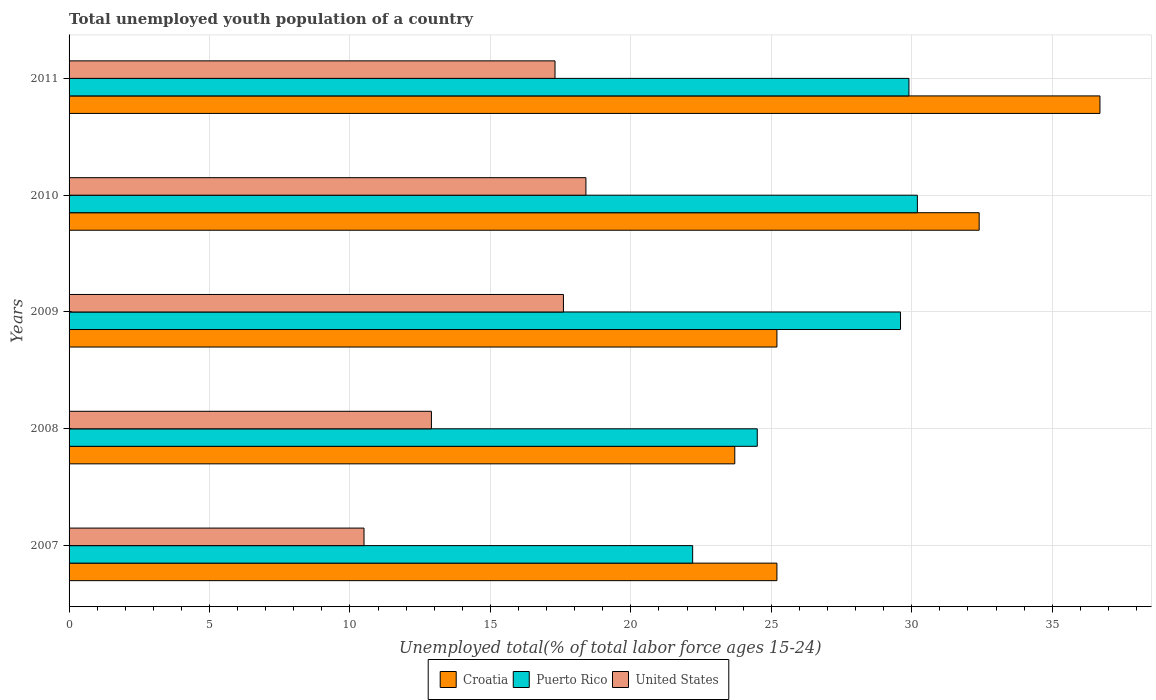Are the number of bars per tick equal to the number of legend labels?
Provide a short and direct response. Yes. How many bars are there on the 2nd tick from the top?
Ensure brevity in your answer.  3. In how many cases, is the number of bars for a given year not equal to the number of legend labels?
Your answer should be compact. 0. What is the percentage of total unemployed youth population of a country in Puerto Rico in 2011?
Your answer should be compact. 29.9. Across all years, what is the maximum percentage of total unemployed youth population of a country in United States?
Make the answer very short. 18.4. Across all years, what is the minimum percentage of total unemployed youth population of a country in Croatia?
Your answer should be very brief. 23.7. In which year was the percentage of total unemployed youth population of a country in Puerto Rico minimum?
Give a very brief answer. 2007. What is the total percentage of total unemployed youth population of a country in Croatia in the graph?
Your answer should be very brief. 143.2. What is the difference between the percentage of total unemployed youth population of a country in Croatia in 2009 and that in 2010?
Give a very brief answer. -7.2. What is the difference between the percentage of total unemployed youth population of a country in Puerto Rico in 2010 and the percentage of total unemployed youth population of a country in United States in 2011?
Make the answer very short. 12.9. What is the average percentage of total unemployed youth population of a country in United States per year?
Provide a succinct answer. 15.34. In the year 2009, what is the difference between the percentage of total unemployed youth population of a country in United States and percentage of total unemployed youth population of a country in Puerto Rico?
Your answer should be very brief. -12. What is the ratio of the percentage of total unemployed youth population of a country in Puerto Rico in 2009 to that in 2010?
Your answer should be very brief. 0.98. Is the percentage of total unemployed youth population of a country in Croatia in 2009 less than that in 2011?
Offer a very short reply. Yes. What is the difference between the highest and the second highest percentage of total unemployed youth population of a country in Croatia?
Offer a terse response. 4.3. What is the difference between the highest and the lowest percentage of total unemployed youth population of a country in Croatia?
Give a very brief answer. 13. What does the 3rd bar from the top in 2010 represents?
Provide a short and direct response. Croatia. What does the 1st bar from the bottom in 2009 represents?
Make the answer very short. Croatia. Is it the case that in every year, the sum of the percentage of total unemployed youth population of a country in Croatia and percentage of total unemployed youth population of a country in Puerto Rico is greater than the percentage of total unemployed youth population of a country in United States?
Give a very brief answer. Yes. How many bars are there?
Offer a very short reply. 15. Does the graph contain any zero values?
Your answer should be very brief. No. Where does the legend appear in the graph?
Give a very brief answer. Bottom center. How many legend labels are there?
Your response must be concise. 3. What is the title of the graph?
Your answer should be very brief. Total unemployed youth population of a country. What is the label or title of the X-axis?
Offer a very short reply. Unemployed total(% of total labor force ages 15-24). What is the label or title of the Y-axis?
Your response must be concise. Years. What is the Unemployed total(% of total labor force ages 15-24) of Croatia in 2007?
Provide a succinct answer. 25.2. What is the Unemployed total(% of total labor force ages 15-24) in Puerto Rico in 2007?
Your answer should be compact. 22.2. What is the Unemployed total(% of total labor force ages 15-24) of Croatia in 2008?
Your response must be concise. 23.7. What is the Unemployed total(% of total labor force ages 15-24) of United States in 2008?
Your answer should be compact. 12.9. What is the Unemployed total(% of total labor force ages 15-24) of Croatia in 2009?
Provide a succinct answer. 25.2. What is the Unemployed total(% of total labor force ages 15-24) in Puerto Rico in 2009?
Ensure brevity in your answer.  29.6. What is the Unemployed total(% of total labor force ages 15-24) of United States in 2009?
Offer a terse response. 17.6. What is the Unemployed total(% of total labor force ages 15-24) in Croatia in 2010?
Provide a short and direct response. 32.4. What is the Unemployed total(% of total labor force ages 15-24) of Puerto Rico in 2010?
Provide a short and direct response. 30.2. What is the Unemployed total(% of total labor force ages 15-24) of United States in 2010?
Offer a very short reply. 18.4. What is the Unemployed total(% of total labor force ages 15-24) of Croatia in 2011?
Your response must be concise. 36.7. What is the Unemployed total(% of total labor force ages 15-24) in Puerto Rico in 2011?
Make the answer very short. 29.9. What is the Unemployed total(% of total labor force ages 15-24) of United States in 2011?
Make the answer very short. 17.3. Across all years, what is the maximum Unemployed total(% of total labor force ages 15-24) of Croatia?
Make the answer very short. 36.7. Across all years, what is the maximum Unemployed total(% of total labor force ages 15-24) in Puerto Rico?
Offer a terse response. 30.2. Across all years, what is the maximum Unemployed total(% of total labor force ages 15-24) of United States?
Your response must be concise. 18.4. Across all years, what is the minimum Unemployed total(% of total labor force ages 15-24) in Croatia?
Give a very brief answer. 23.7. Across all years, what is the minimum Unemployed total(% of total labor force ages 15-24) of Puerto Rico?
Keep it short and to the point. 22.2. Across all years, what is the minimum Unemployed total(% of total labor force ages 15-24) of United States?
Ensure brevity in your answer.  10.5. What is the total Unemployed total(% of total labor force ages 15-24) of Croatia in the graph?
Give a very brief answer. 143.2. What is the total Unemployed total(% of total labor force ages 15-24) in Puerto Rico in the graph?
Your answer should be very brief. 136.4. What is the total Unemployed total(% of total labor force ages 15-24) in United States in the graph?
Offer a very short reply. 76.7. What is the difference between the Unemployed total(% of total labor force ages 15-24) in Puerto Rico in 2007 and that in 2008?
Provide a short and direct response. -2.3. What is the difference between the Unemployed total(% of total labor force ages 15-24) in Croatia in 2007 and that in 2009?
Keep it short and to the point. 0. What is the difference between the Unemployed total(% of total labor force ages 15-24) of Puerto Rico in 2007 and that in 2009?
Make the answer very short. -7.4. What is the difference between the Unemployed total(% of total labor force ages 15-24) of United States in 2007 and that in 2009?
Keep it short and to the point. -7.1. What is the difference between the Unemployed total(% of total labor force ages 15-24) of Puerto Rico in 2007 and that in 2011?
Your response must be concise. -7.7. What is the difference between the Unemployed total(% of total labor force ages 15-24) of United States in 2007 and that in 2011?
Give a very brief answer. -6.8. What is the difference between the Unemployed total(% of total labor force ages 15-24) of Croatia in 2008 and that in 2010?
Your answer should be very brief. -8.7. What is the difference between the Unemployed total(% of total labor force ages 15-24) of United States in 2008 and that in 2011?
Offer a very short reply. -4.4. What is the difference between the Unemployed total(% of total labor force ages 15-24) of Croatia in 2009 and that in 2010?
Provide a succinct answer. -7.2. What is the difference between the Unemployed total(% of total labor force ages 15-24) of Puerto Rico in 2009 and that in 2010?
Keep it short and to the point. -0.6. What is the difference between the Unemployed total(% of total labor force ages 15-24) in United States in 2009 and that in 2010?
Your response must be concise. -0.8. What is the difference between the Unemployed total(% of total labor force ages 15-24) in Croatia in 2010 and that in 2011?
Make the answer very short. -4.3. What is the difference between the Unemployed total(% of total labor force ages 15-24) of United States in 2010 and that in 2011?
Provide a short and direct response. 1.1. What is the difference between the Unemployed total(% of total labor force ages 15-24) in Croatia in 2007 and the Unemployed total(% of total labor force ages 15-24) in Puerto Rico in 2008?
Ensure brevity in your answer.  0.7. What is the difference between the Unemployed total(% of total labor force ages 15-24) of Puerto Rico in 2007 and the Unemployed total(% of total labor force ages 15-24) of United States in 2008?
Your answer should be compact. 9.3. What is the difference between the Unemployed total(% of total labor force ages 15-24) in Puerto Rico in 2007 and the Unemployed total(% of total labor force ages 15-24) in United States in 2009?
Your answer should be compact. 4.6. What is the difference between the Unemployed total(% of total labor force ages 15-24) of Croatia in 2007 and the Unemployed total(% of total labor force ages 15-24) of United States in 2010?
Ensure brevity in your answer.  6.8. What is the difference between the Unemployed total(% of total labor force ages 15-24) in Puerto Rico in 2007 and the Unemployed total(% of total labor force ages 15-24) in United States in 2010?
Offer a terse response. 3.8. What is the difference between the Unemployed total(% of total labor force ages 15-24) of Croatia in 2007 and the Unemployed total(% of total labor force ages 15-24) of Puerto Rico in 2011?
Offer a terse response. -4.7. What is the difference between the Unemployed total(% of total labor force ages 15-24) of Puerto Rico in 2008 and the Unemployed total(% of total labor force ages 15-24) of United States in 2009?
Provide a short and direct response. 6.9. What is the difference between the Unemployed total(% of total labor force ages 15-24) of Croatia in 2008 and the Unemployed total(% of total labor force ages 15-24) of United States in 2011?
Offer a very short reply. 6.4. What is the difference between the Unemployed total(% of total labor force ages 15-24) in Croatia in 2009 and the Unemployed total(% of total labor force ages 15-24) in Puerto Rico in 2010?
Your response must be concise. -5. What is the difference between the Unemployed total(% of total labor force ages 15-24) in Croatia in 2009 and the Unemployed total(% of total labor force ages 15-24) in United States in 2010?
Keep it short and to the point. 6.8. What is the difference between the Unemployed total(% of total labor force ages 15-24) in Puerto Rico in 2009 and the Unemployed total(% of total labor force ages 15-24) in United States in 2010?
Offer a very short reply. 11.2. What is the difference between the Unemployed total(% of total labor force ages 15-24) of Croatia in 2009 and the Unemployed total(% of total labor force ages 15-24) of Puerto Rico in 2011?
Make the answer very short. -4.7. What is the difference between the Unemployed total(% of total labor force ages 15-24) of Puerto Rico in 2009 and the Unemployed total(% of total labor force ages 15-24) of United States in 2011?
Provide a succinct answer. 12.3. What is the average Unemployed total(% of total labor force ages 15-24) in Croatia per year?
Give a very brief answer. 28.64. What is the average Unemployed total(% of total labor force ages 15-24) in Puerto Rico per year?
Provide a succinct answer. 27.28. What is the average Unemployed total(% of total labor force ages 15-24) in United States per year?
Provide a short and direct response. 15.34. In the year 2007, what is the difference between the Unemployed total(% of total labor force ages 15-24) of Croatia and Unemployed total(% of total labor force ages 15-24) of Puerto Rico?
Your answer should be compact. 3. In the year 2007, what is the difference between the Unemployed total(% of total labor force ages 15-24) of Puerto Rico and Unemployed total(% of total labor force ages 15-24) of United States?
Your response must be concise. 11.7. In the year 2009, what is the difference between the Unemployed total(% of total labor force ages 15-24) in Croatia and Unemployed total(% of total labor force ages 15-24) in United States?
Offer a very short reply. 7.6. In the year 2010, what is the difference between the Unemployed total(% of total labor force ages 15-24) of Croatia and Unemployed total(% of total labor force ages 15-24) of Puerto Rico?
Give a very brief answer. 2.2. In the year 2010, what is the difference between the Unemployed total(% of total labor force ages 15-24) in Croatia and Unemployed total(% of total labor force ages 15-24) in United States?
Your response must be concise. 14. In the year 2010, what is the difference between the Unemployed total(% of total labor force ages 15-24) of Puerto Rico and Unemployed total(% of total labor force ages 15-24) of United States?
Offer a terse response. 11.8. In the year 2011, what is the difference between the Unemployed total(% of total labor force ages 15-24) in Croatia and Unemployed total(% of total labor force ages 15-24) in Puerto Rico?
Provide a short and direct response. 6.8. In the year 2011, what is the difference between the Unemployed total(% of total labor force ages 15-24) in Croatia and Unemployed total(% of total labor force ages 15-24) in United States?
Keep it short and to the point. 19.4. What is the ratio of the Unemployed total(% of total labor force ages 15-24) of Croatia in 2007 to that in 2008?
Offer a terse response. 1.06. What is the ratio of the Unemployed total(% of total labor force ages 15-24) of Puerto Rico in 2007 to that in 2008?
Make the answer very short. 0.91. What is the ratio of the Unemployed total(% of total labor force ages 15-24) in United States in 2007 to that in 2008?
Offer a very short reply. 0.81. What is the ratio of the Unemployed total(% of total labor force ages 15-24) in United States in 2007 to that in 2009?
Provide a short and direct response. 0.6. What is the ratio of the Unemployed total(% of total labor force ages 15-24) of Puerto Rico in 2007 to that in 2010?
Provide a short and direct response. 0.74. What is the ratio of the Unemployed total(% of total labor force ages 15-24) of United States in 2007 to that in 2010?
Your response must be concise. 0.57. What is the ratio of the Unemployed total(% of total labor force ages 15-24) of Croatia in 2007 to that in 2011?
Offer a very short reply. 0.69. What is the ratio of the Unemployed total(% of total labor force ages 15-24) of Puerto Rico in 2007 to that in 2011?
Your answer should be compact. 0.74. What is the ratio of the Unemployed total(% of total labor force ages 15-24) in United States in 2007 to that in 2011?
Provide a succinct answer. 0.61. What is the ratio of the Unemployed total(% of total labor force ages 15-24) in Croatia in 2008 to that in 2009?
Your response must be concise. 0.94. What is the ratio of the Unemployed total(% of total labor force ages 15-24) in Puerto Rico in 2008 to that in 2009?
Provide a succinct answer. 0.83. What is the ratio of the Unemployed total(% of total labor force ages 15-24) in United States in 2008 to that in 2009?
Your answer should be compact. 0.73. What is the ratio of the Unemployed total(% of total labor force ages 15-24) in Croatia in 2008 to that in 2010?
Your answer should be compact. 0.73. What is the ratio of the Unemployed total(% of total labor force ages 15-24) of Puerto Rico in 2008 to that in 2010?
Keep it short and to the point. 0.81. What is the ratio of the Unemployed total(% of total labor force ages 15-24) in United States in 2008 to that in 2010?
Your answer should be compact. 0.7. What is the ratio of the Unemployed total(% of total labor force ages 15-24) of Croatia in 2008 to that in 2011?
Your answer should be very brief. 0.65. What is the ratio of the Unemployed total(% of total labor force ages 15-24) of Puerto Rico in 2008 to that in 2011?
Your response must be concise. 0.82. What is the ratio of the Unemployed total(% of total labor force ages 15-24) of United States in 2008 to that in 2011?
Your answer should be compact. 0.75. What is the ratio of the Unemployed total(% of total labor force ages 15-24) in Croatia in 2009 to that in 2010?
Your response must be concise. 0.78. What is the ratio of the Unemployed total(% of total labor force ages 15-24) of Puerto Rico in 2009 to that in 2010?
Provide a short and direct response. 0.98. What is the ratio of the Unemployed total(% of total labor force ages 15-24) in United States in 2009 to that in 2010?
Keep it short and to the point. 0.96. What is the ratio of the Unemployed total(% of total labor force ages 15-24) in Croatia in 2009 to that in 2011?
Give a very brief answer. 0.69. What is the ratio of the Unemployed total(% of total labor force ages 15-24) in Puerto Rico in 2009 to that in 2011?
Your response must be concise. 0.99. What is the ratio of the Unemployed total(% of total labor force ages 15-24) of United States in 2009 to that in 2011?
Make the answer very short. 1.02. What is the ratio of the Unemployed total(% of total labor force ages 15-24) in Croatia in 2010 to that in 2011?
Ensure brevity in your answer.  0.88. What is the ratio of the Unemployed total(% of total labor force ages 15-24) in Puerto Rico in 2010 to that in 2011?
Make the answer very short. 1.01. What is the ratio of the Unemployed total(% of total labor force ages 15-24) of United States in 2010 to that in 2011?
Your answer should be very brief. 1.06. What is the difference between the highest and the second highest Unemployed total(% of total labor force ages 15-24) of Croatia?
Your answer should be compact. 4.3. What is the difference between the highest and the second highest Unemployed total(% of total labor force ages 15-24) of United States?
Offer a terse response. 0.8. What is the difference between the highest and the lowest Unemployed total(% of total labor force ages 15-24) in United States?
Make the answer very short. 7.9. 